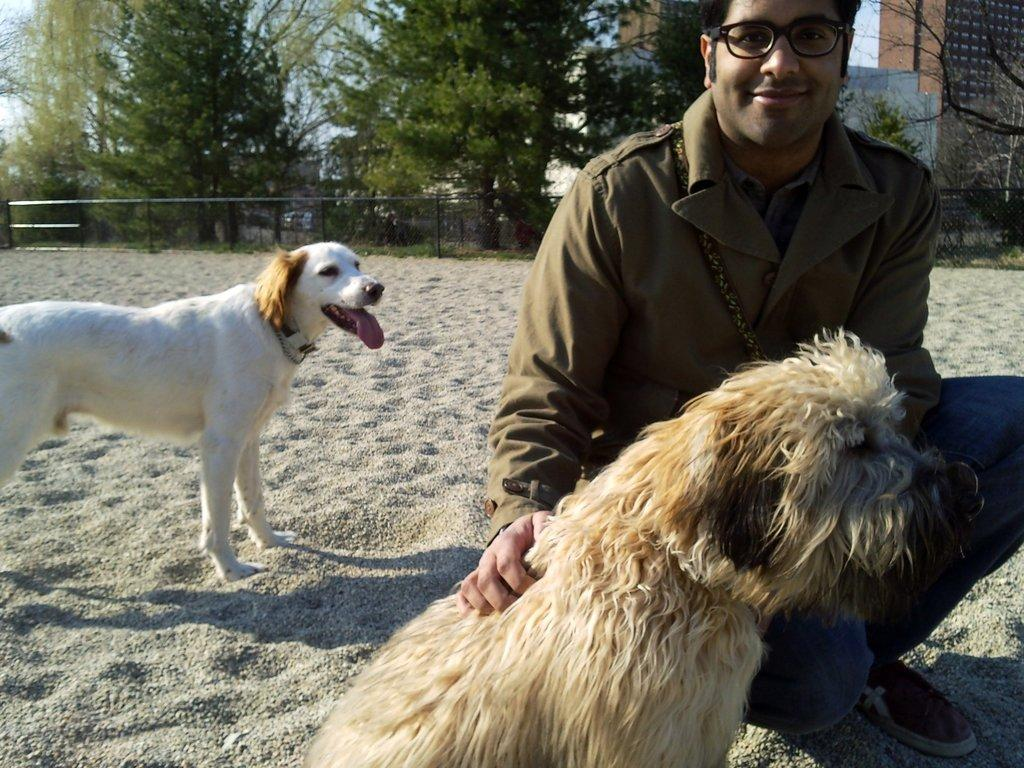How many dogs are in the image? There are two dogs in the image. What is the man in the image wearing? The man is wearing a spectacle, a coat, jeans, and shoes. What can be seen in the background of the image? There is a fence, buildings, trees, and the sky visible in the background of the image. What type of quartz can be seen in the image? There is no quartz present in the image. What is the border between the fence and the trees in the image? The image does not show a border between the fence and the trees; it only shows the fence and the trees separately. 